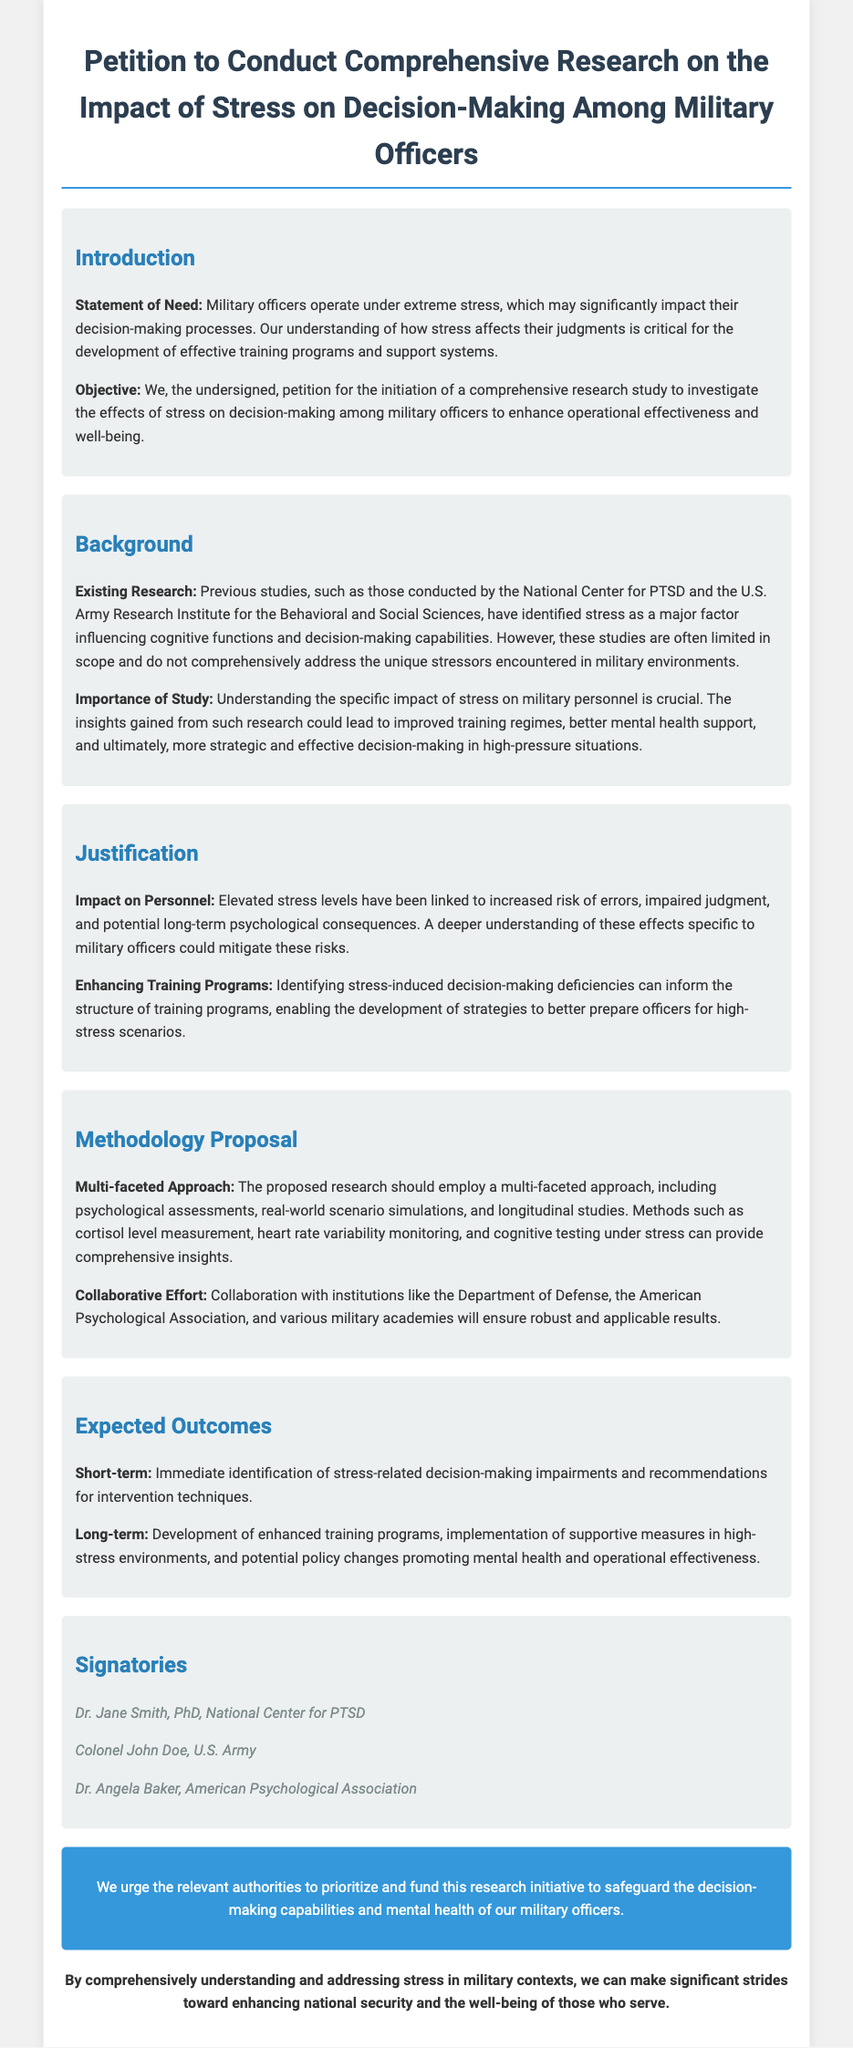What is the title of the petition? The title of the petition is found at the top of the document, summarizing its purpose.
Answer: Petition to Conduct Comprehensive Research on the Impact of Stress on Decision-Making Among Military Officers Who authored the petition? The petition lists several signatories who are advocating for the research, indicating the authorship.
Answer: Dr. Jane Smith, Colonel John Doe, Dr. Angela Baker What is the stated objective of the petition? The document outlines the objective within the introduction section, stating what the petition seeks to achieve.
Answer: Initiation of a comprehensive research study What type of research approaches are proposed? The methodology section describes the approach advocated for the research, detailing the methods envisioned.
Answer: Multi-faceted approach What is identified as a significant factor influencing decision-making? The background section mentions a key variable in decision-making of military officers.
Answer: Stress What are the expected short-term outcomes of the research? The expected outcomes section describes what is hoped to be achieved shortly after the research is conducted.
Answer: Immediate identification of stress-related decision-making impairments What kind of collaboration is suggested for the research? The methodology proposal discusses the importance of teamwork with various institutions to conduct the study effectively.
Answer: Collaboration with institutions like the Department of Defense What psychological aspect is specifically measured in the proposed research? The methodology section proposes specific metrics to assess personnel under stress in the study.
Answer: Cortisol level measurement What is the closing remark about the significance of the research? The closing remark summarizes the overall importance of understanding stress in military contexts.
Answer: Enhancing national security and the well-being of those who serve 